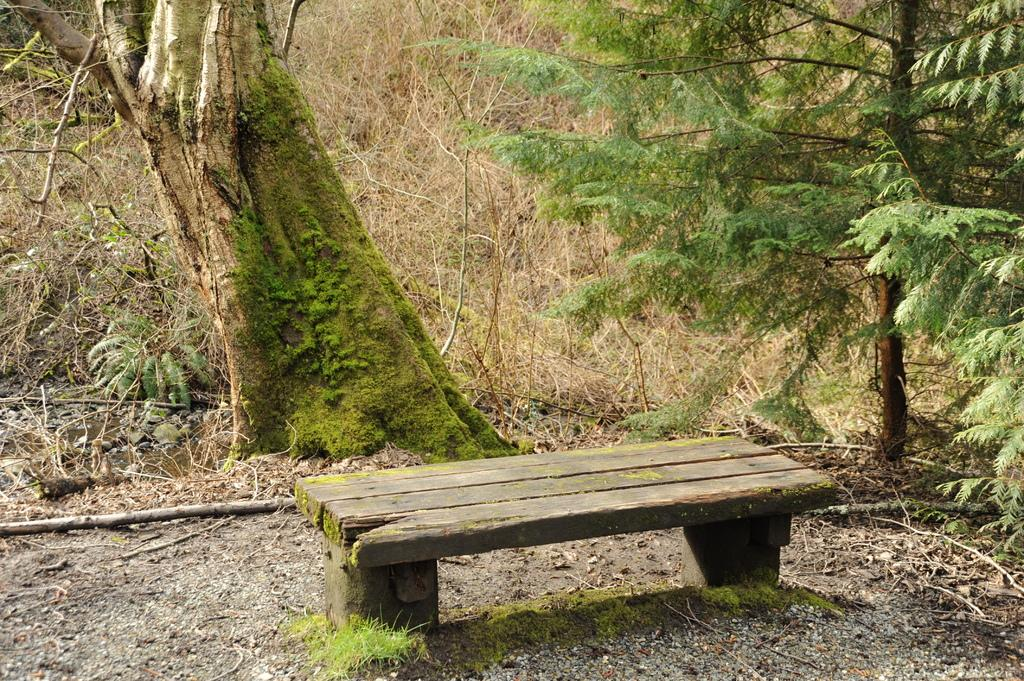What type of seating is present in the image? There is a bench in the image. What can be seen behind the bench? There are trees behind the bench. What type of ground is visible in the image? There is grass visible in the image. What is growing on the tree trunk? There is moss on the tree trunk. What type of punishment is being administered to the monkey in the image? There is no monkey present in the image, so no punishment can be observed. 